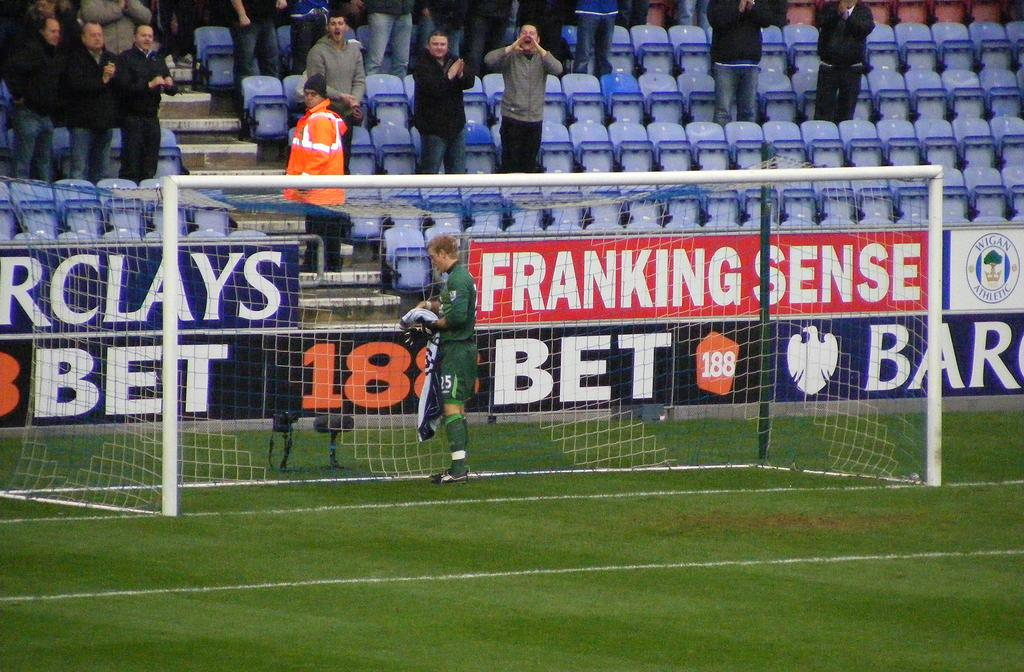<image>
Write a terse but informative summary of the picture. a soccer player in a goal by ads for Franking Sense 